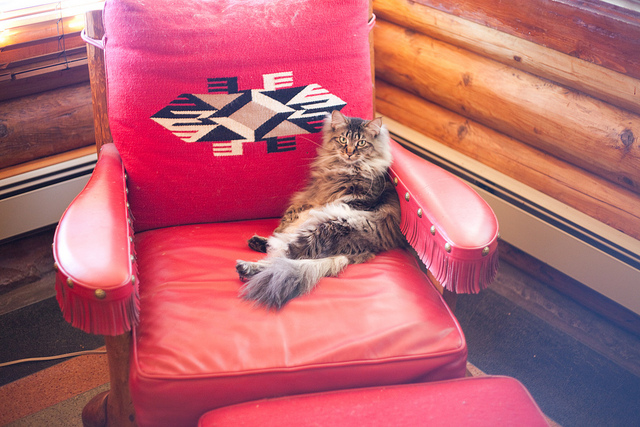<image>What color is the couch? The color of the couch could be red. What color is the couch? I don't know what color the couch is. It can be red. 